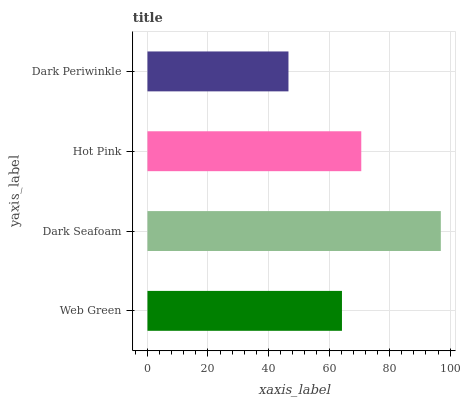Is Dark Periwinkle the minimum?
Answer yes or no. Yes. Is Dark Seafoam the maximum?
Answer yes or no. Yes. Is Hot Pink the minimum?
Answer yes or no. No. Is Hot Pink the maximum?
Answer yes or no. No. Is Dark Seafoam greater than Hot Pink?
Answer yes or no. Yes. Is Hot Pink less than Dark Seafoam?
Answer yes or no. Yes. Is Hot Pink greater than Dark Seafoam?
Answer yes or no. No. Is Dark Seafoam less than Hot Pink?
Answer yes or no. No. Is Hot Pink the high median?
Answer yes or no. Yes. Is Web Green the low median?
Answer yes or no. Yes. Is Dark Periwinkle the high median?
Answer yes or no. No. Is Dark Periwinkle the low median?
Answer yes or no. No. 